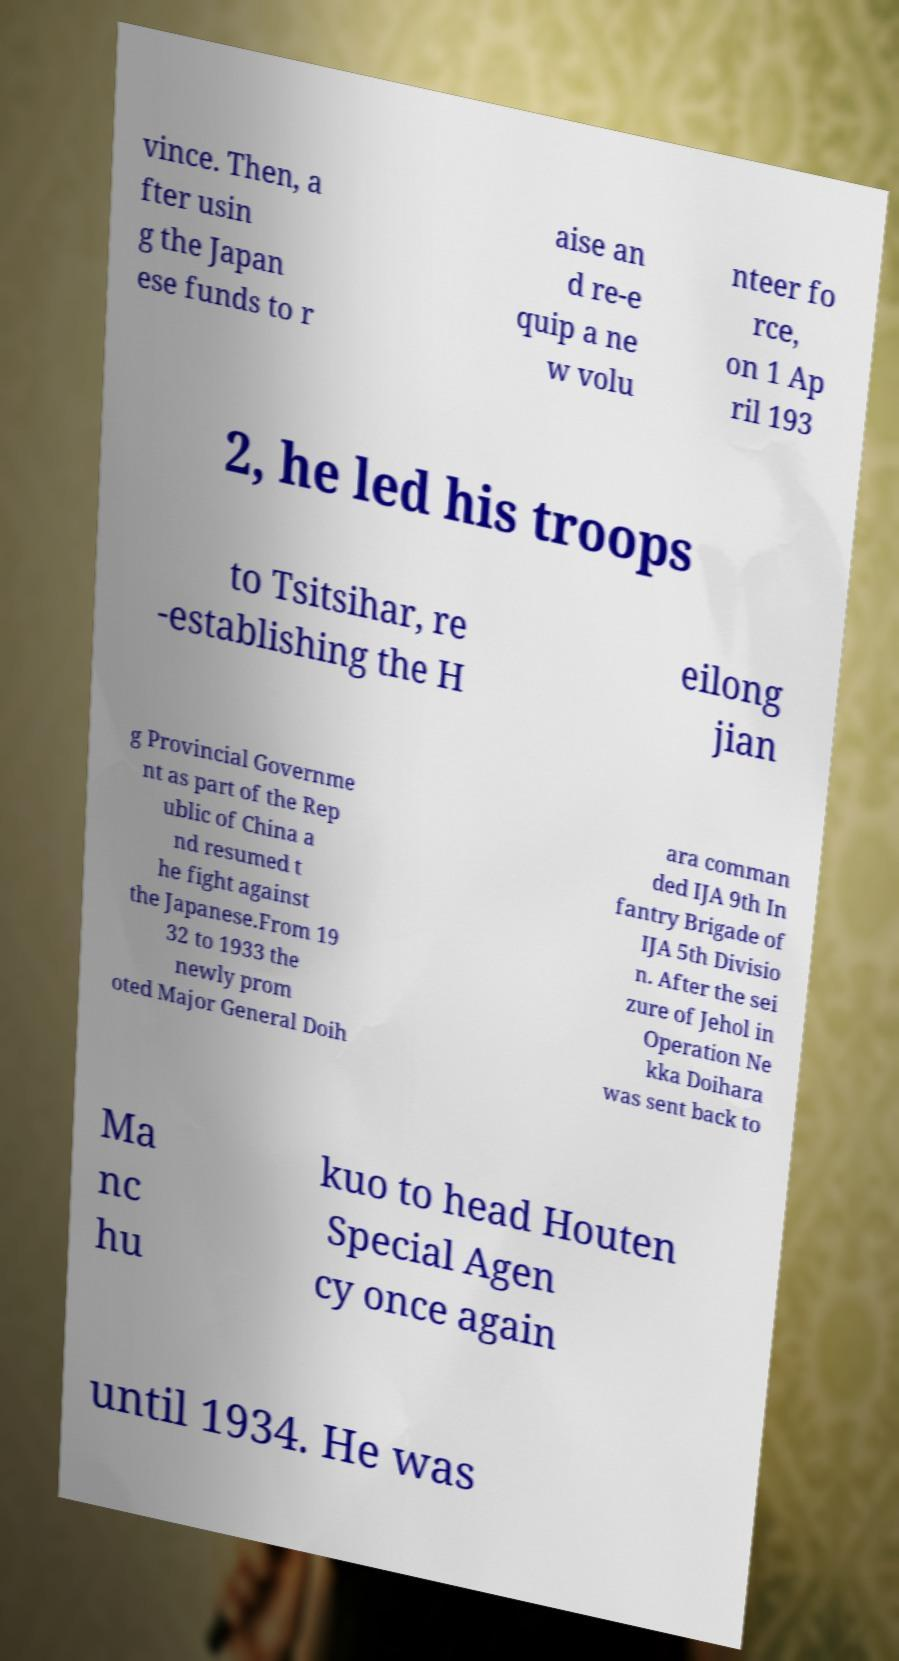Could you extract and type out the text from this image? vince. Then, a fter usin g the Japan ese funds to r aise an d re-e quip a ne w volu nteer fo rce, on 1 Ap ril 193 2, he led his troops to Tsitsihar, re -establishing the H eilong jian g Provincial Governme nt as part of the Rep ublic of China a nd resumed t he fight against the Japanese.From 19 32 to 1933 the newly prom oted Major General Doih ara comman ded IJA 9th In fantry Brigade of IJA 5th Divisio n. After the sei zure of Jehol in Operation Ne kka Doihara was sent back to Ma nc hu kuo to head Houten Special Agen cy once again until 1934. He was 